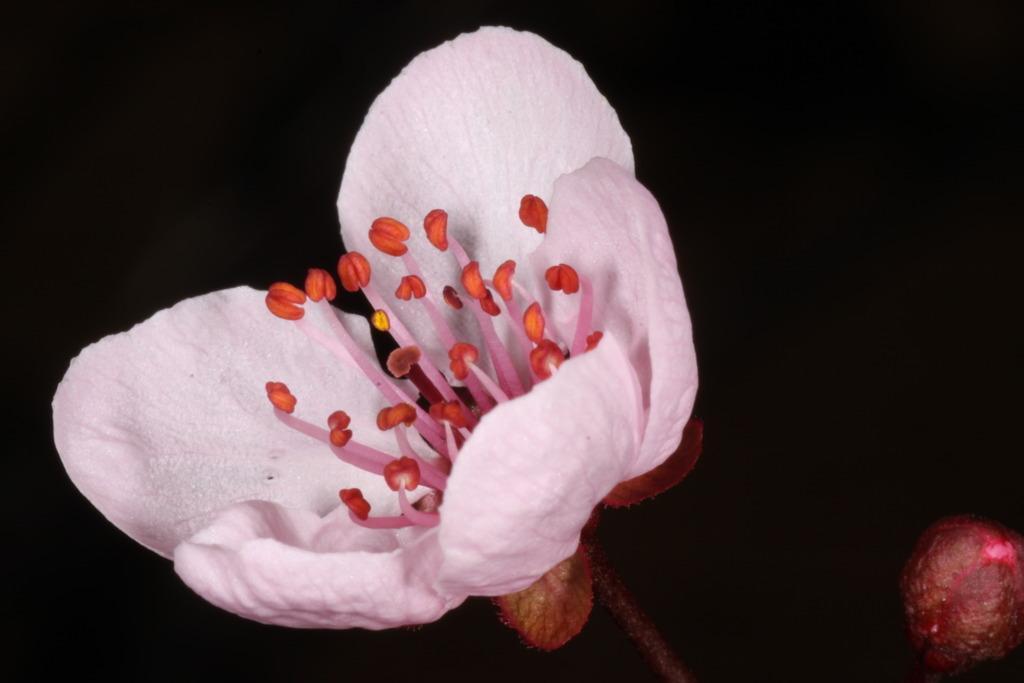Can you describe this image briefly? This is a zoomed in picture. In the foreground we can see the pink color flower and the stem of a flower. The background of the image is very dark. On the right corner there is an object. 